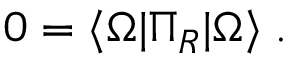<formula> <loc_0><loc_0><loc_500><loc_500>0 = \langle \Omega | \Pi _ { R } | \Omega \rangle \, .</formula> 